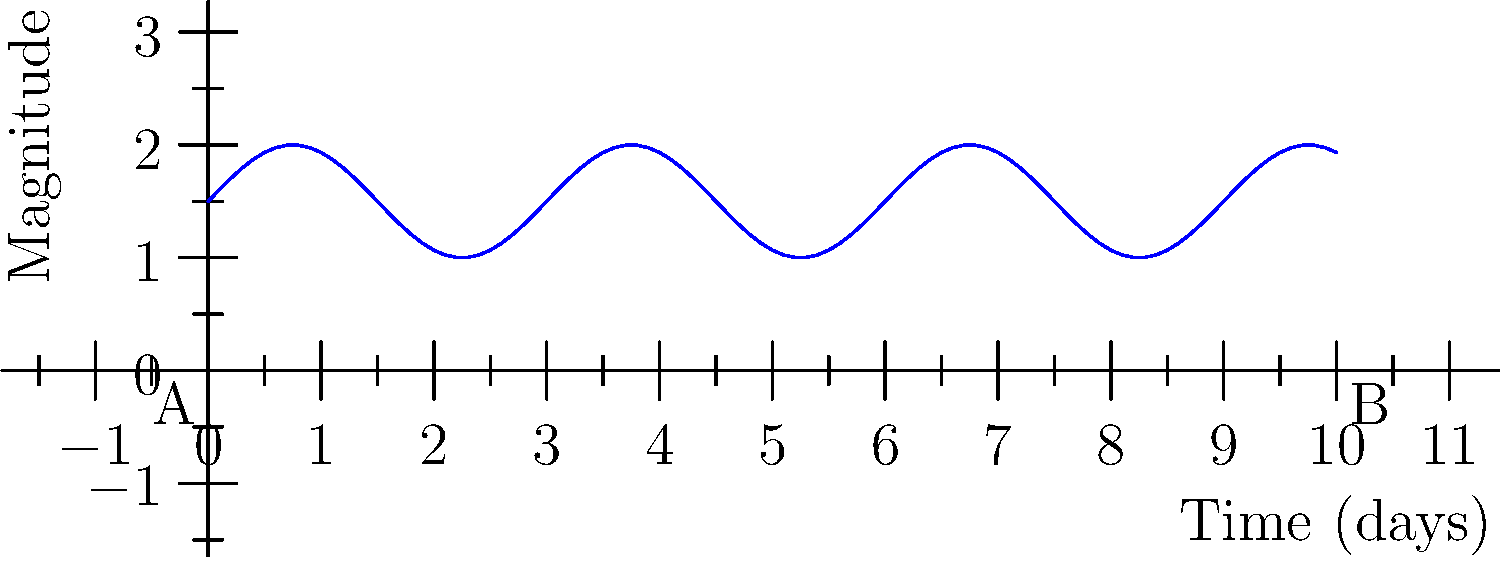Given the light curve of a variable star shown above, what type of variability is most likely represented, and what is the approximate period of the star's variation in days? To determine the type of variability and the period of the star, we need to analyze the light curve:

1. Shape of the curve: The light curve shows a smooth, sinusoidal pattern. This is characteristic of pulsating variable stars, particularly Cepheid variables or RR Lyrae stars.

2. Regularity: The pattern repeats consistently, indicating a regular periodic variation.

3. Period calculation:
   a. Identify two consecutive peaks or troughs.
   b. Measure the time interval between them.
   c. In this case, we can see that the distance between two consecutive peaks is about 3 days.

4. Magnitude variation: The variation in magnitude (brightness) is relatively small, about 1 magnitude between maximum and minimum.

5. Duration of variation: The entire cycle completes in a short time frame (days), which is consistent with Cepheid or RR Lyrae variables.

Based on these observations, this light curve most likely represents a pulsating variable star, such as a Cepheid variable or an RR Lyrae star. The period of the variation is approximately 3 days, as seen from the distance between consecutive peaks or troughs in the light curve.
Answer: Pulsating variable (e.g., Cepheid or RR Lyrae), 3 days 